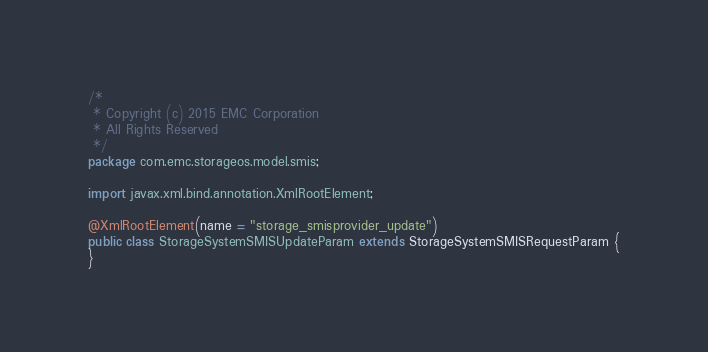Convert code to text. <code><loc_0><loc_0><loc_500><loc_500><_Java_>/*
 * Copyright (c) 2015 EMC Corporation
 * All Rights Reserved
 */
package com.emc.storageos.model.smis;

import javax.xml.bind.annotation.XmlRootElement;

@XmlRootElement(name = "storage_smisprovider_update")
public class StorageSystemSMISUpdateParam extends StorageSystemSMISRequestParam {
}
</code> 